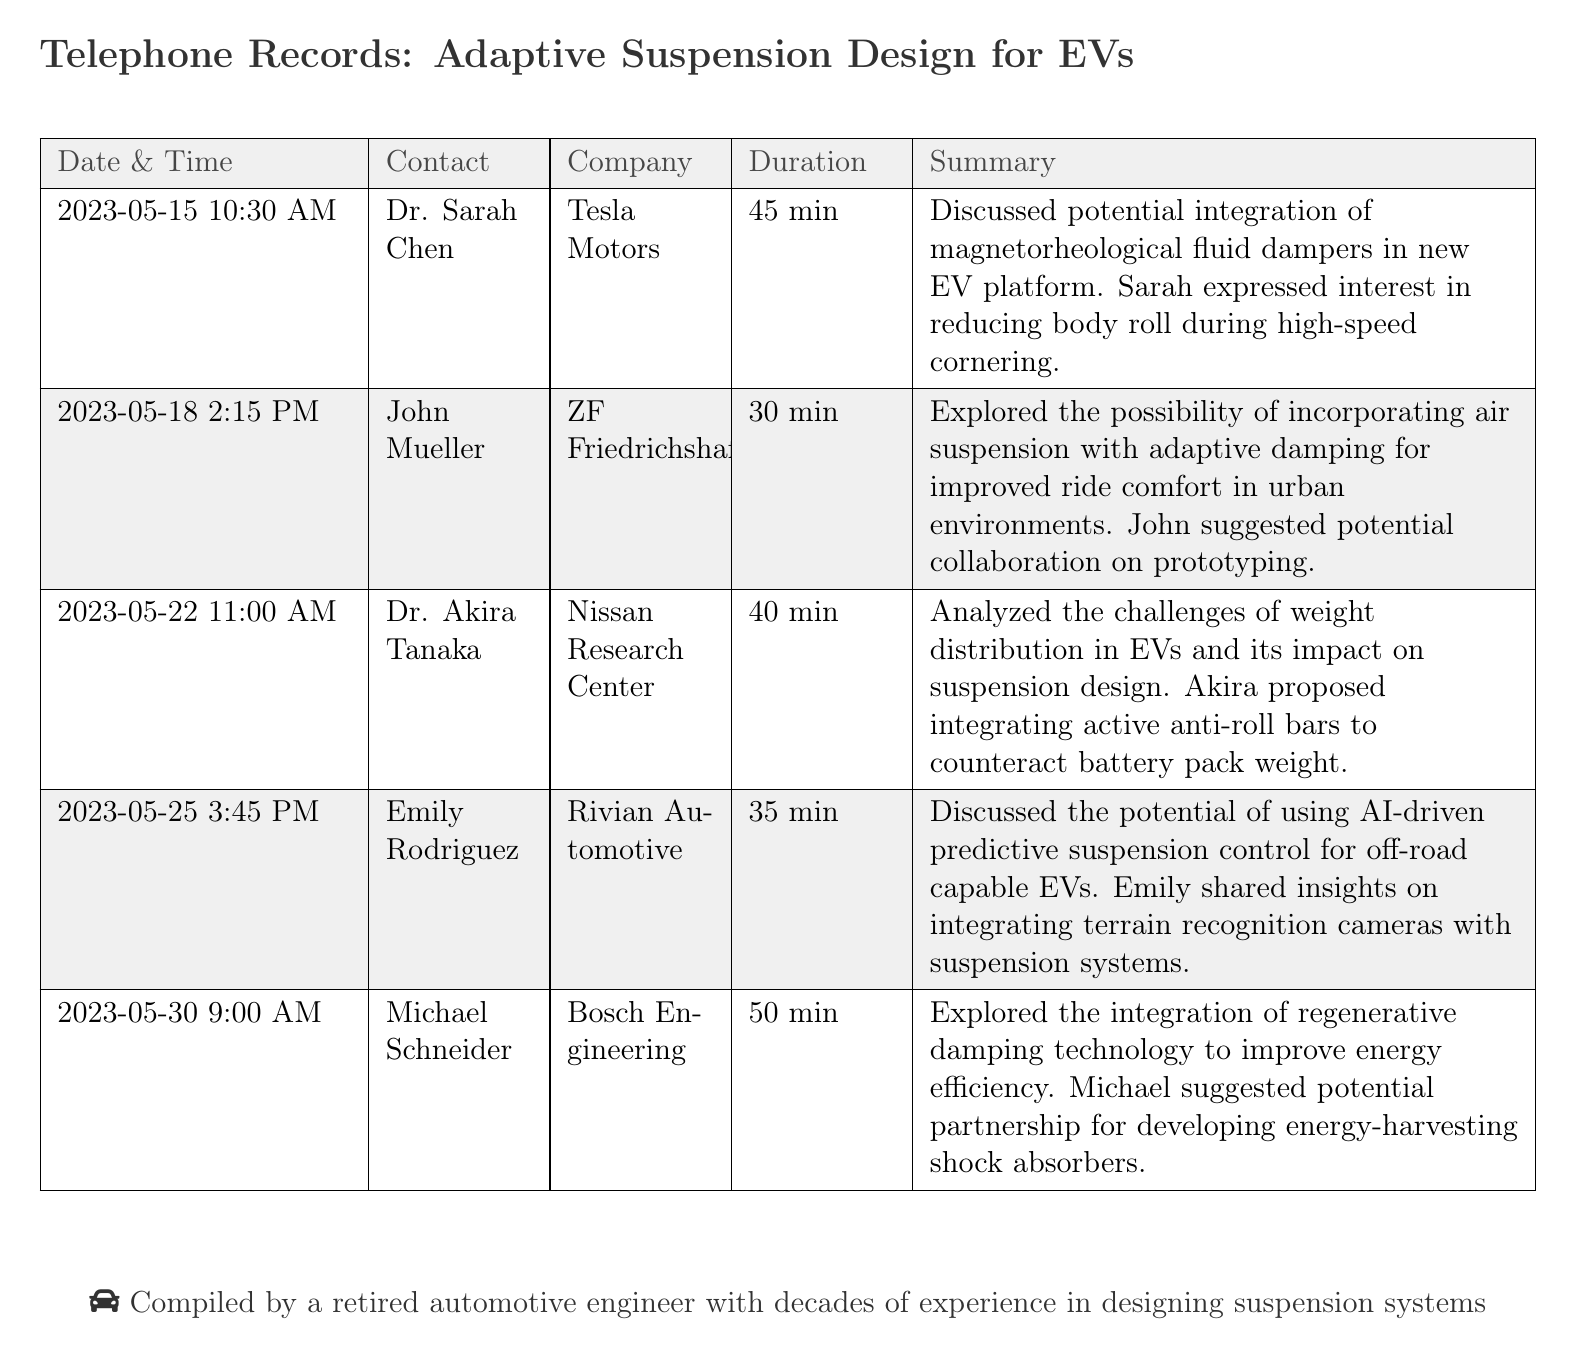What is the date of the first call? The date of the first call is listed at the top of the call log, which is May 15, 2023.
Answer: May 15, 2023 Who is Dr. Sarah Chen's employer? Dr. Sarah Chen's employer is mentioned in the call log as Tesla Motors.
Answer: Tesla Motors How long was the call with John Mueller? The duration of the call with John Mueller is recorded as 30 minutes.
Answer: 30 min What innovative technology did Michael Schneider discuss? Michael Schneider discussed the integration of regenerative damping technology during his call.
Answer: Regenerative damping technology What issue did Dr. Akira Tanaka focus on during the discussion? The issue that Dr. Akira Tanaka focused on was weight distribution in EVs and its impact on suspension design.
Answer: Weight distribution in EVs What type of suspension did Emily Rodriguez suggest using for off-road EVs? Emily Rodriguez suggested using AI-driven predictive suspension control for off-road capable EVs.
Answer: AI-driven predictive suspension control How many minutes did the call with Dr. Akira Tanaka last? The call with Dr. Akira Tanaka lasted for 40 minutes according to the log.
Answer: 40 min What was the main interest of Sarah Chen in her call? Sarah Chen expressed interest in reducing body roll during high-speed cornering.
Answer: Reducing body roll What additional technology was discussed for the collaboration with John Mueller? The collaboration discussed with John Mueller involved incorporating air suspension with adaptive damping.
Answer: Air suspension with adaptive damping 